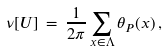Convert formula to latex. <formula><loc_0><loc_0><loc_500><loc_500>\nu [ U ] \, = \, \frac { 1 } { 2 \pi } \sum _ { x \in \Lambda } \theta _ { P } ( x ) \, ,</formula> 